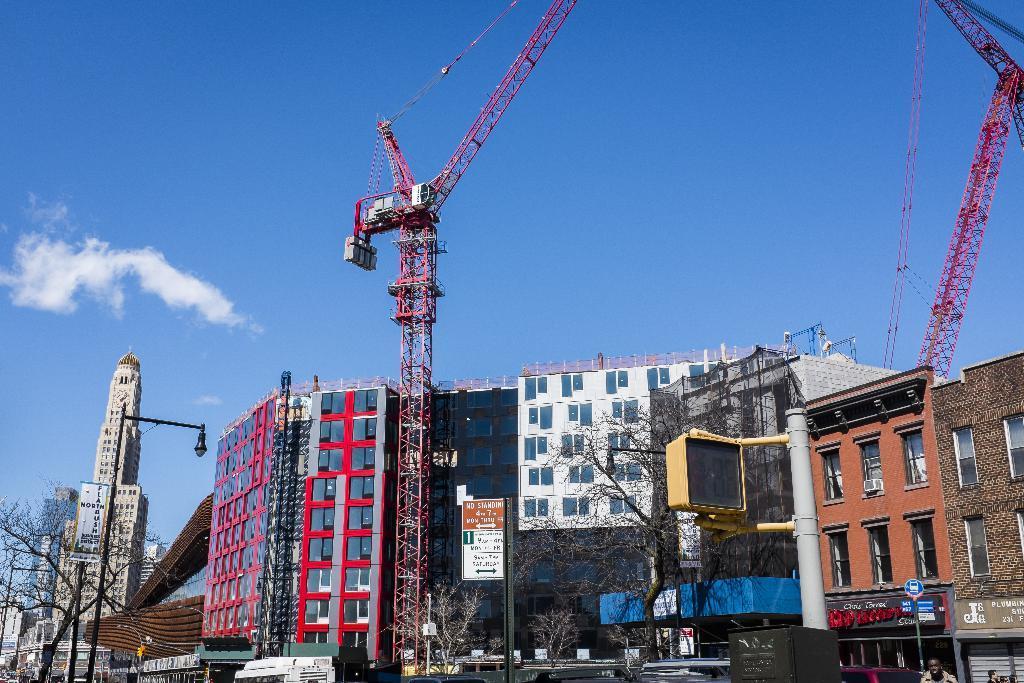In one or two sentences, can you explain what this image depicts? This picture is clicked outside the city. Here, we see a tower in red color. There are many buildings. Beside the tower, we see a white board with some text written on it. We even see street lights. There are trees beside the buildings. At the top of the picture, we see the sky, which is blue in color. 